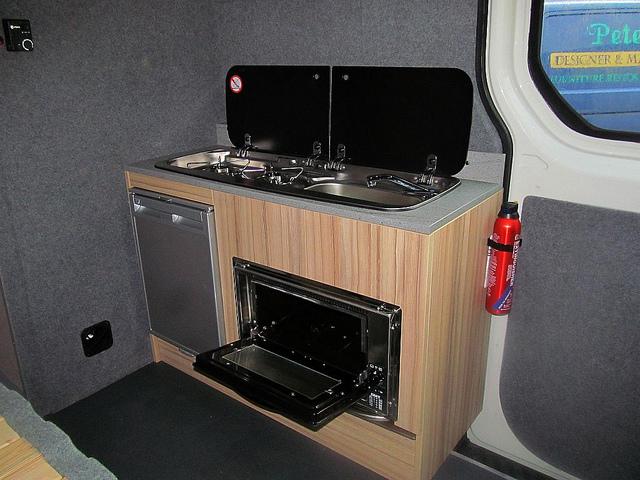Could you bake several cakes at once in this oven?
Give a very brief answer. No. Is this room in a house?
Short answer required. No. What color is the wall?
Give a very brief answer. Gray. What does the sign say?
Give a very brief answer. Pete. What is this machine in the picture?
Short answer required. Stove. 